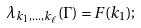<formula> <loc_0><loc_0><loc_500><loc_500>\lambda _ { k _ { 1 } , \dots , k _ { \ell } } ( \Gamma ) = F ( k _ { 1 } ) ;</formula> 